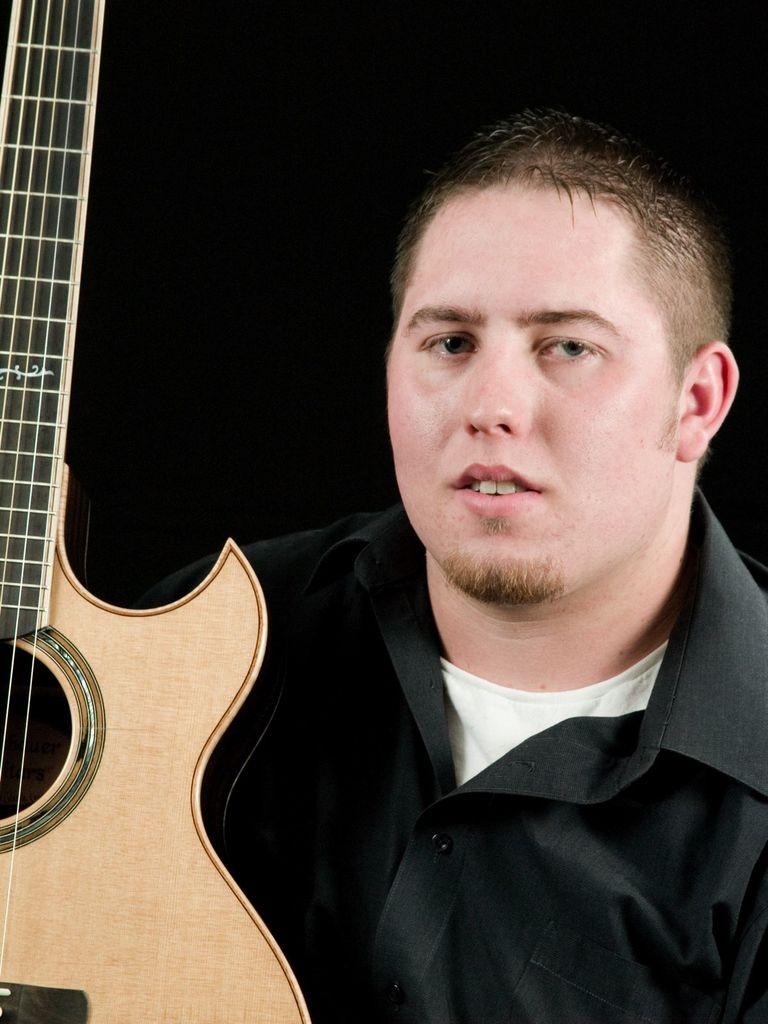What is present in the image? There is a person in the image. What is the person wearing? The person is wearing a black shirt. What object is in front of the person? There is a guitar in front of the person. What type of holiday is being celebrated in the image? There is no indication of a holiday being celebrated in the image. Is there a rod visible in the image? No, there is no rod present in the image. 